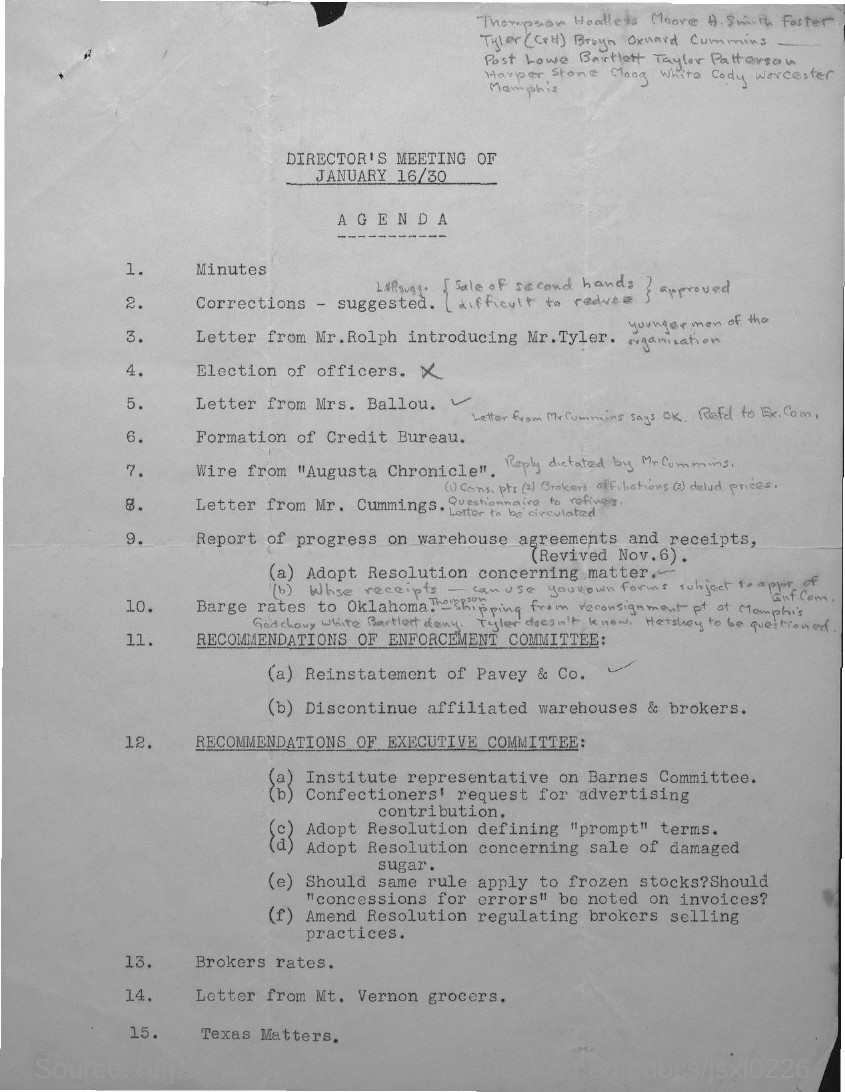Indicate a few pertinent items in this graphic. Agenda item 13 concerns the issue of broker rates, and I would like to know more about it. The Agenda item number 15 is titled 'Texas Matters' and concerns a matter related to Texas. 